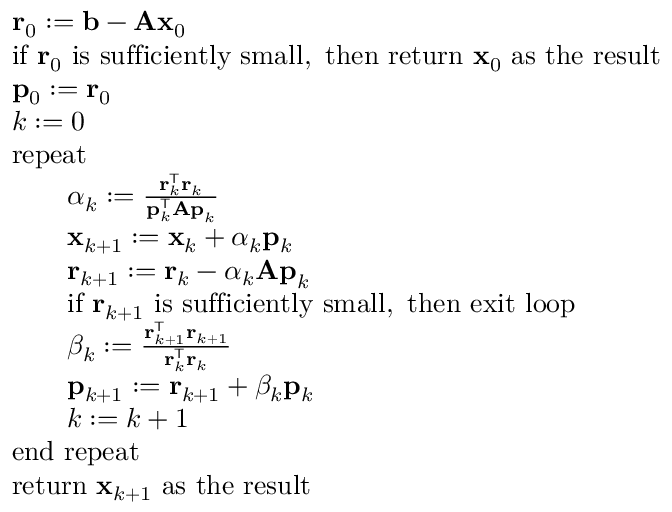Convert formula to latex. <formula><loc_0><loc_0><loc_500><loc_500>{ \begin{array} { r l } & { r _ { 0 } \colon = b - A x _ { 0 } } \\ & { { i f } r _ { 0 } { i s s u f f i c i e n t l y s m a l l , t h e n r e t u r n } x _ { 0 } { a s t h e r e s u l t } } \\ & { p _ { 0 } \colon = r _ { 0 } } \\ & { k \colon = 0 } \\ & { r e p e a t } \\ & { \quad \alpha _ { k } \colon = { \frac { r _ { k } ^ { T } r _ { k } } { p _ { k } ^ { T } A p _ { k } } } } \\ & { \quad x _ { k + 1 } \colon = x _ { k } + \alpha _ { k } p _ { k } } \\ & { \quad r _ { k + 1 } \colon = r _ { k } - \alpha _ { k } A p _ { k } } \\ & { \quad { i f } r _ { k + 1 } { i s s u f f i c i e n t l y s m a l l , t h e n e x i t l o o p } } \\ & { \quad \beta _ { k } \colon = { \frac { r _ { k + 1 } ^ { T } r _ { k + 1 } } { r _ { k } ^ { T } r _ { k } } } } \\ & { \quad p _ { k + 1 } \colon = r _ { k + 1 } + \beta _ { k } p _ { k } } \\ & { \quad k \colon = k + 1 } \\ & { e n d r e p e a t } \\ & { { r e t u r n } x _ { k + 1 } { a s t h e r e s u l t } } \end{array} }</formula> 